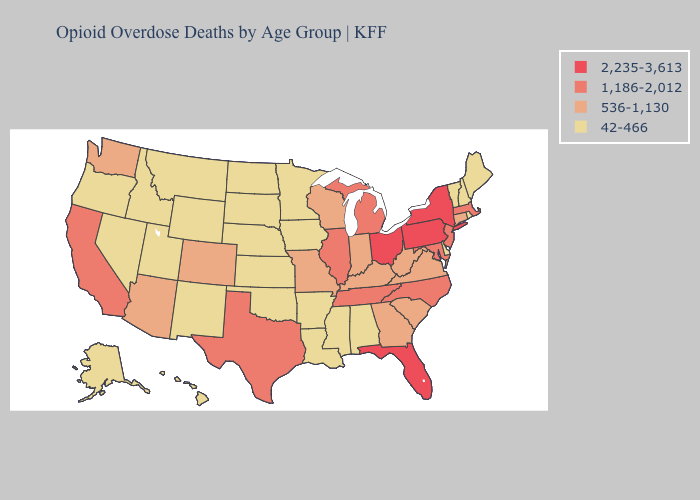Does Alabama have the same value as New Jersey?
Write a very short answer. No. What is the highest value in the USA?
Give a very brief answer. 2,235-3,613. Name the states that have a value in the range 1,186-2,012?
Short answer required. California, Illinois, Maryland, Massachusetts, Michigan, New Jersey, North Carolina, Tennessee, Texas. What is the value of Colorado?
Be succinct. 536-1,130. Is the legend a continuous bar?
Keep it brief. No. Does the first symbol in the legend represent the smallest category?
Concise answer only. No. What is the value of North Dakota?
Be succinct. 42-466. Which states have the lowest value in the MidWest?
Concise answer only. Iowa, Kansas, Minnesota, Nebraska, North Dakota, South Dakota. Which states have the lowest value in the USA?
Concise answer only. Alabama, Alaska, Arkansas, Delaware, Hawaii, Idaho, Iowa, Kansas, Louisiana, Maine, Minnesota, Mississippi, Montana, Nebraska, Nevada, New Hampshire, New Mexico, North Dakota, Oklahoma, Oregon, Rhode Island, South Dakota, Utah, Vermont, Wyoming. Does Illinois have a higher value than Maine?
Concise answer only. Yes. Does Kentucky have a higher value than Tennessee?
Short answer required. No. What is the lowest value in the MidWest?
Answer briefly. 42-466. What is the highest value in the USA?
Write a very short answer. 2,235-3,613. Which states have the highest value in the USA?
Short answer required. Florida, New York, Ohio, Pennsylvania. What is the lowest value in the USA?
Give a very brief answer. 42-466. 